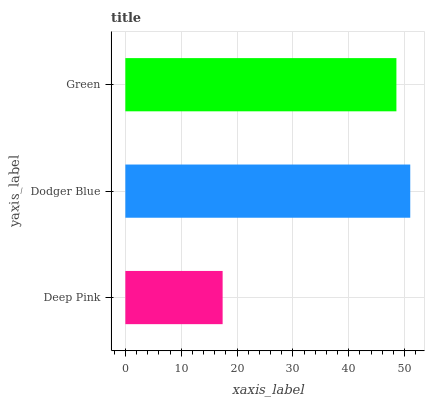Is Deep Pink the minimum?
Answer yes or no. Yes. Is Dodger Blue the maximum?
Answer yes or no. Yes. Is Green the minimum?
Answer yes or no. No. Is Green the maximum?
Answer yes or no. No. Is Dodger Blue greater than Green?
Answer yes or no. Yes. Is Green less than Dodger Blue?
Answer yes or no. Yes. Is Green greater than Dodger Blue?
Answer yes or no. No. Is Dodger Blue less than Green?
Answer yes or no. No. Is Green the high median?
Answer yes or no. Yes. Is Green the low median?
Answer yes or no. Yes. Is Deep Pink the high median?
Answer yes or no. No. Is Dodger Blue the low median?
Answer yes or no. No. 